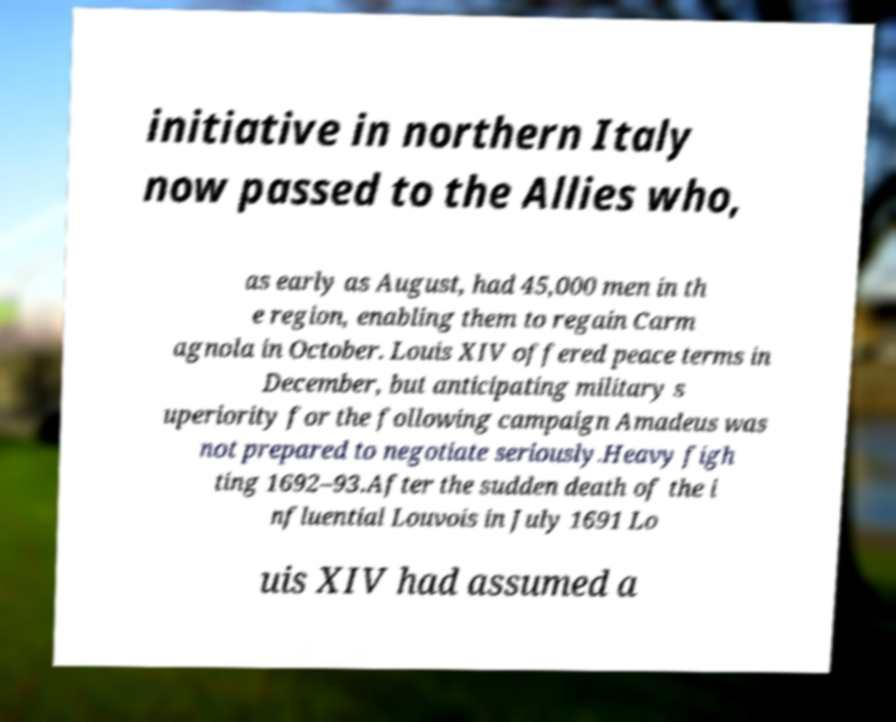Can you read and provide the text displayed in the image?This photo seems to have some interesting text. Can you extract and type it out for me? initiative in northern Italy now passed to the Allies who, as early as August, had 45,000 men in th e region, enabling them to regain Carm agnola in October. Louis XIV offered peace terms in December, but anticipating military s uperiority for the following campaign Amadeus was not prepared to negotiate seriously.Heavy figh ting 1692–93.After the sudden death of the i nfluential Louvois in July 1691 Lo uis XIV had assumed a 